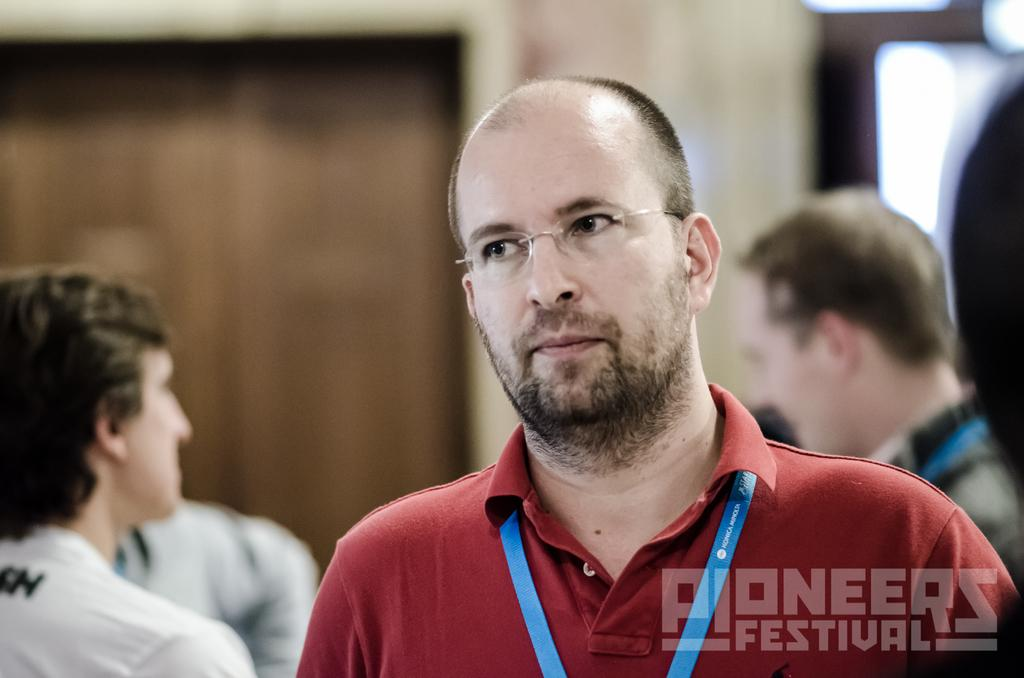What is the appearance of the person in the image? There is a person wearing clothes and spectacles in the image. How many other people are visible in the image? There are two other people wearing clothes in the image, one in the bottom left and another in the bottom right. What religion is the person in the image practicing? There is no information about the person's religion in the image. 